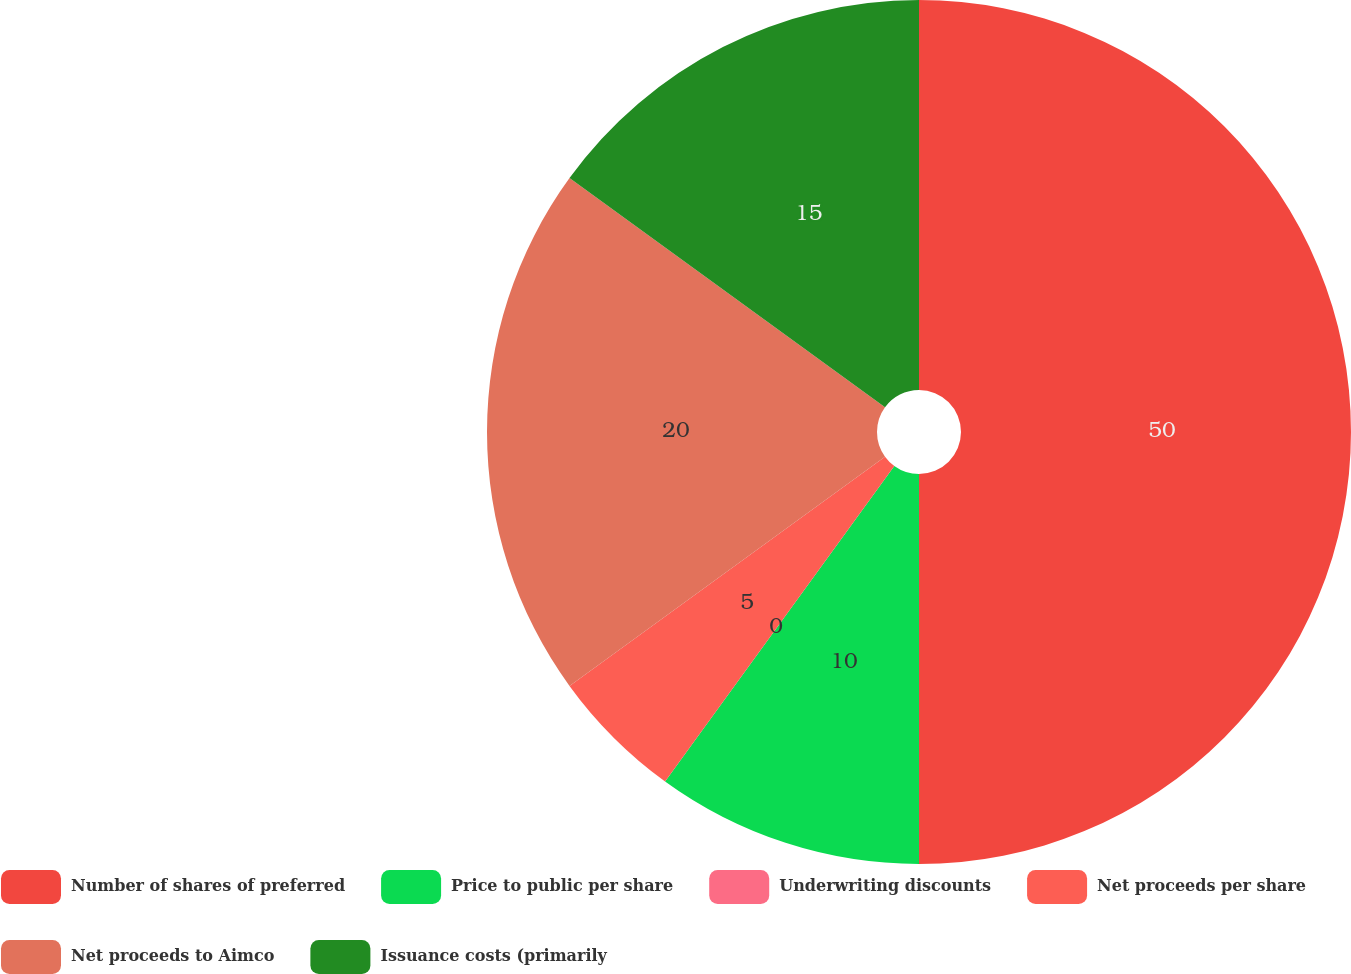<chart> <loc_0><loc_0><loc_500><loc_500><pie_chart><fcel>Number of shares of preferred<fcel>Price to public per share<fcel>Underwriting discounts<fcel>Net proceeds per share<fcel>Net proceeds to Aimco<fcel>Issuance costs (primarily<nl><fcel>50.0%<fcel>10.0%<fcel>0.0%<fcel>5.0%<fcel>20.0%<fcel>15.0%<nl></chart> 